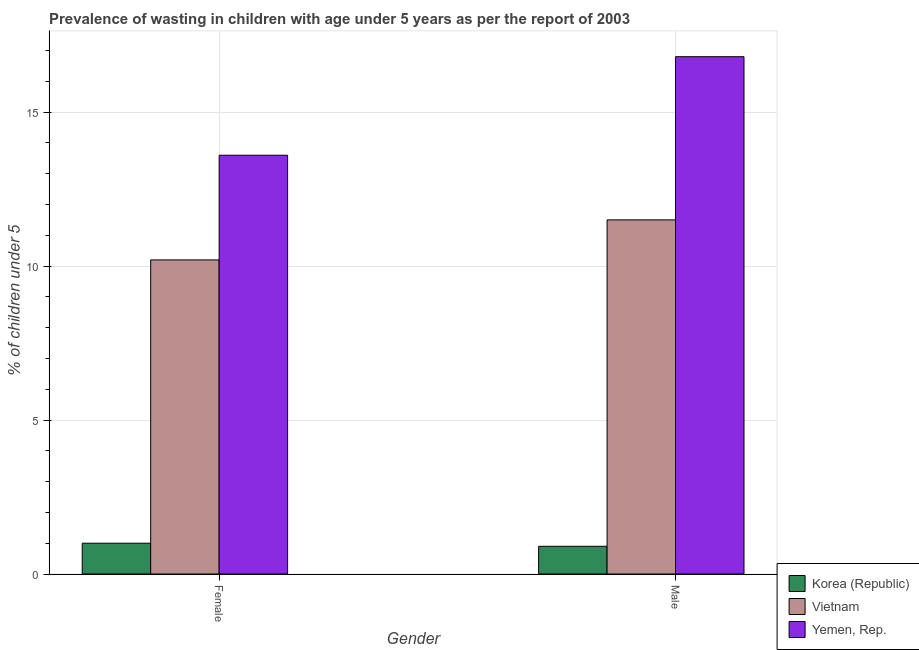How many different coloured bars are there?
Offer a very short reply. 3. How many groups of bars are there?
Keep it short and to the point. 2. Are the number of bars per tick equal to the number of legend labels?
Your answer should be compact. Yes. Are the number of bars on each tick of the X-axis equal?
Offer a very short reply. Yes. How many bars are there on the 2nd tick from the left?
Offer a terse response. 3. How many bars are there on the 2nd tick from the right?
Keep it short and to the point. 3. What is the label of the 1st group of bars from the left?
Offer a very short reply. Female. What is the percentage of undernourished female children in Korea (Republic)?
Your answer should be very brief. 1. Across all countries, what is the maximum percentage of undernourished female children?
Provide a succinct answer. 13.6. In which country was the percentage of undernourished male children maximum?
Keep it short and to the point. Yemen, Rep. What is the total percentage of undernourished male children in the graph?
Provide a short and direct response. 29.2. What is the difference between the percentage of undernourished female children in Korea (Republic) and that in Vietnam?
Your response must be concise. -9.2. What is the difference between the percentage of undernourished female children in Yemen, Rep. and the percentage of undernourished male children in Vietnam?
Give a very brief answer. 2.1. What is the average percentage of undernourished female children per country?
Make the answer very short. 8.27. What is the difference between the percentage of undernourished male children and percentage of undernourished female children in Vietnam?
Your answer should be very brief. 1.3. What is the ratio of the percentage of undernourished female children in Korea (Republic) to that in Yemen, Rep.?
Ensure brevity in your answer.  0.07. What does the 2nd bar from the right in Female represents?
Your answer should be very brief. Vietnam. How many bars are there?
Make the answer very short. 6. Are all the bars in the graph horizontal?
Your answer should be compact. No. How many countries are there in the graph?
Your answer should be compact. 3. What is the difference between two consecutive major ticks on the Y-axis?
Your answer should be compact. 5. Does the graph contain any zero values?
Make the answer very short. No. Where does the legend appear in the graph?
Provide a succinct answer. Bottom right. How are the legend labels stacked?
Provide a succinct answer. Vertical. What is the title of the graph?
Ensure brevity in your answer.  Prevalence of wasting in children with age under 5 years as per the report of 2003. What is the label or title of the Y-axis?
Your response must be concise.  % of children under 5. What is the  % of children under 5 of Korea (Republic) in Female?
Your answer should be very brief. 1. What is the  % of children under 5 of Vietnam in Female?
Give a very brief answer. 10.2. What is the  % of children under 5 of Yemen, Rep. in Female?
Provide a short and direct response. 13.6. What is the  % of children under 5 in Korea (Republic) in Male?
Offer a very short reply. 0.9. What is the  % of children under 5 of Vietnam in Male?
Ensure brevity in your answer.  11.5. What is the  % of children under 5 in Yemen, Rep. in Male?
Your answer should be very brief. 16.8. Across all Gender, what is the maximum  % of children under 5 of Korea (Republic)?
Make the answer very short. 1. Across all Gender, what is the maximum  % of children under 5 of Vietnam?
Your answer should be very brief. 11.5. Across all Gender, what is the maximum  % of children under 5 of Yemen, Rep.?
Your answer should be compact. 16.8. Across all Gender, what is the minimum  % of children under 5 in Korea (Republic)?
Offer a very short reply. 0.9. Across all Gender, what is the minimum  % of children under 5 of Vietnam?
Offer a terse response. 10.2. Across all Gender, what is the minimum  % of children under 5 of Yemen, Rep.?
Keep it short and to the point. 13.6. What is the total  % of children under 5 of Korea (Republic) in the graph?
Your answer should be very brief. 1.9. What is the total  % of children under 5 of Vietnam in the graph?
Ensure brevity in your answer.  21.7. What is the total  % of children under 5 of Yemen, Rep. in the graph?
Provide a succinct answer. 30.4. What is the difference between the  % of children under 5 in Korea (Republic) in Female and that in Male?
Give a very brief answer. 0.1. What is the difference between the  % of children under 5 of Yemen, Rep. in Female and that in Male?
Offer a very short reply. -3.2. What is the difference between the  % of children under 5 of Korea (Republic) in Female and the  % of children under 5 of Vietnam in Male?
Make the answer very short. -10.5. What is the difference between the  % of children under 5 in Korea (Republic) in Female and the  % of children under 5 in Yemen, Rep. in Male?
Your answer should be very brief. -15.8. What is the difference between the  % of children under 5 in Vietnam in Female and the  % of children under 5 in Yemen, Rep. in Male?
Provide a short and direct response. -6.6. What is the average  % of children under 5 in Vietnam per Gender?
Offer a very short reply. 10.85. What is the difference between the  % of children under 5 of Korea (Republic) and  % of children under 5 of Yemen, Rep. in Female?
Your response must be concise. -12.6. What is the difference between the  % of children under 5 in Vietnam and  % of children under 5 in Yemen, Rep. in Female?
Offer a terse response. -3.4. What is the difference between the  % of children under 5 of Korea (Republic) and  % of children under 5 of Yemen, Rep. in Male?
Offer a terse response. -15.9. What is the difference between the  % of children under 5 in Vietnam and  % of children under 5 in Yemen, Rep. in Male?
Your response must be concise. -5.3. What is the ratio of the  % of children under 5 in Vietnam in Female to that in Male?
Make the answer very short. 0.89. What is the ratio of the  % of children under 5 of Yemen, Rep. in Female to that in Male?
Offer a very short reply. 0.81. What is the difference between the highest and the second highest  % of children under 5 in Korea (Republic)?
Give a very brief answer. 0.1. What is the difference between the highest and the second highest  % of children under 5 in Yemen, Rep.?
Your answer should be compact. 3.2. What is the difference between the highest and the lowest  % of children under 5 in Vietnam?
Your response must be concise. 1.3. 